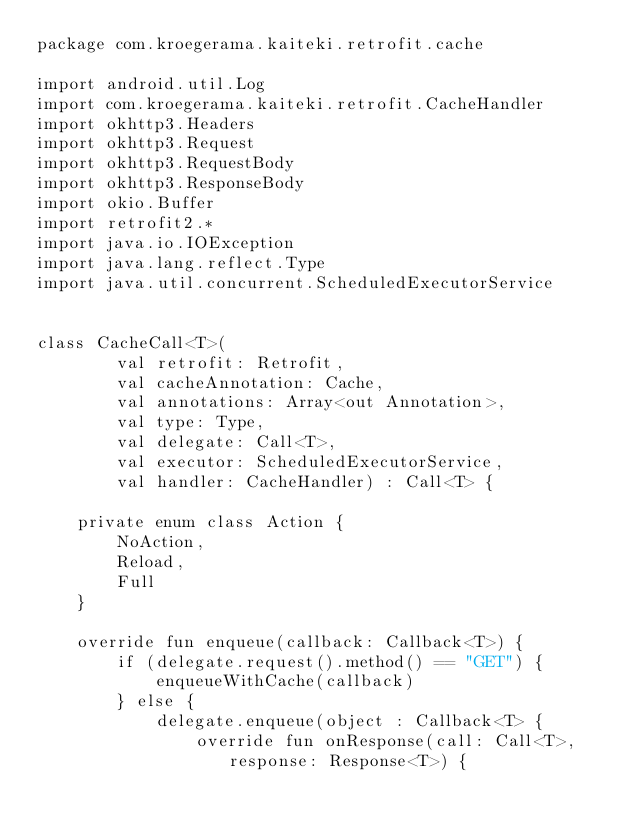Convert code to text. <code><loc_0><loc_0><loc_500><loc_500><_Kotlin_>package com.kroegerama.kaiteki.retrofit.cache

import android.util.Log
import com.kroegerama.kaiteki.retrofit.CacheHandler
import okhttp3.Headers
import okhttp3.Request
import okhttp3.RequestBody
import okhttp3.ResponseBody
import okio.Buffer
import retrofit2.*
import java.io.IOException
import java.lang.reflect.Type
import java.util.concurrent.ScheduledExecutorService


class CacheCall<T>(
        val retrofit: Retrofit,
        val cacheAnnotation: Cache,
        val annotations: Array<out Annotation>,
        val type: Type,
        val delegate: Call<T>,
        val executor: ScheduledExecutorService,
        val handler: CacheHandler) : Call<T> {

    private enum class Action {
        NoAction,
        Reload,
        Full
    }

    override fun enqueue(callback: Callback<T>) {
        if (delegate.request().method() == "GET") {
            enqueueWithCache(callback)
        } else {
            delegate.enqueue(object : Callback<T> {
                override fun onResponse(call: Call<T>, response: Response<T>) {</code> 